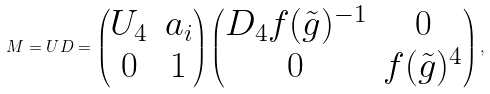<formula> <loc_0><loc_0><loc_500><loc_500>M = U D = \begin{pmatrix} U _ { 4 } & a _ { i } \\ 0 & 1 \end{pmatrix} \begin{pmatrix} D _ { 4 } f ( \tilde { g } ) ^ { - 1 } & 0 \\ 0 & f ( \tilde { g } ) ^ { 4 } \end{pmatrix} ,</formula> 